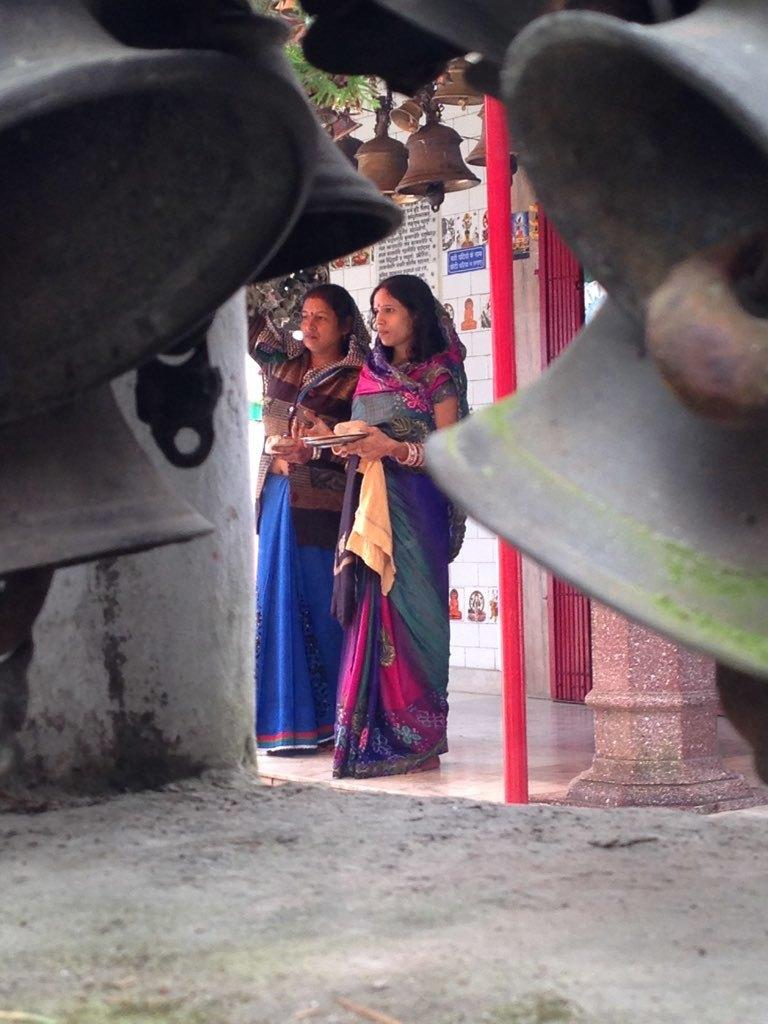What objects are present in the image that are associated with making noise? There are bells in the image that are associated with making noise. What are the two people in the image doing? The two people in the image are standing and holding something. What is the color of the pole in the image? The pole in the image is red. What type of structure can be seen in the image that might control access? There is a gate in the image that might control access. What type of architectural feature is present in the image? There is a wall in the image. What type of chalk is being used to draw on the wall in the image? There is no chalk present in the image, nor is there any drawing on the wall. How does the red pole twist in the image? The red pole does not twist in the image; it is stationary. What type of weather condition is depicted in the image? There is no indication of weather conditions in the image. 